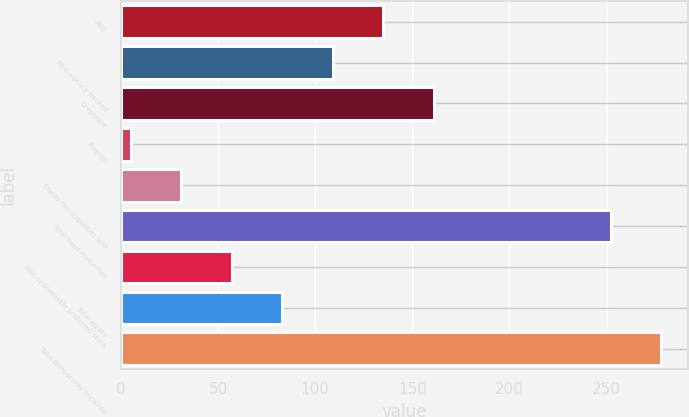Convert chart. <chart><loc_0><loc_0><loc_500><loc_500><bar_chart><fcel>ABS<fcel>Non-agency backed<fcel>Corporate<fcel>Foreign<fcel>States municipalities and<fcel>Total fixed maturities<fcel>Non-redeemable preferred stock<fcel>Total equity<fcel>Total temporarily impaired<nl><fcel>135<fcel>109<fcel>161<fcel>5<fcel>31<fcel>252<fcel>57<fcel>83<fcel>278<nl></chart> 